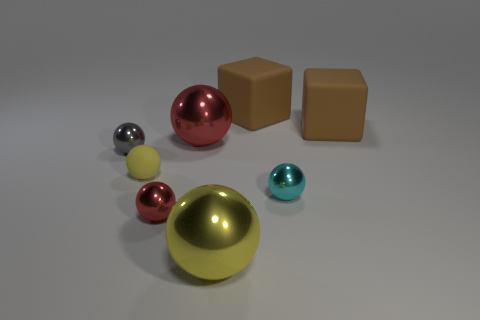Is there another purple rubber thing that has the same shape as the tiny rubber thing?
Make the answer very short. No. Are there the same number of tiny yellow rubber balls to the right of the tiny yellow object and brown rubber things that are in front of the small red metallic ball?
Give a very brief answer. Yes. There is a large brown thing that is on the left side of the cyan thing; is it the same shape as the small red object?
Your response must be concise. No. Do the small red metallic object and the tiny yellow thing have the same shape?
Your answer should be very brief. Yes. What number of metal objects are big objects or brown blocks?
Your response must be concise. 2. What material is the large thing that is the same color as the tiny rubber sphere?
Your response must be concise. Metal. Do the matte ball and the cyan shiny sphere have the same size?
Provide a succinct answer. Yes. What number of things are small gray things or shiny spheres that are in front of the small yellow rubber thing?
Provide a succinct answer. 4. What material is the red object that is the same size as the yellow rubber ball?
Keep it short and to the point. Metal. What material is the tiny thing that is behind the tiny cyan object and in front of the tiny gray sphere?
Your response must be concise. Rubber. 